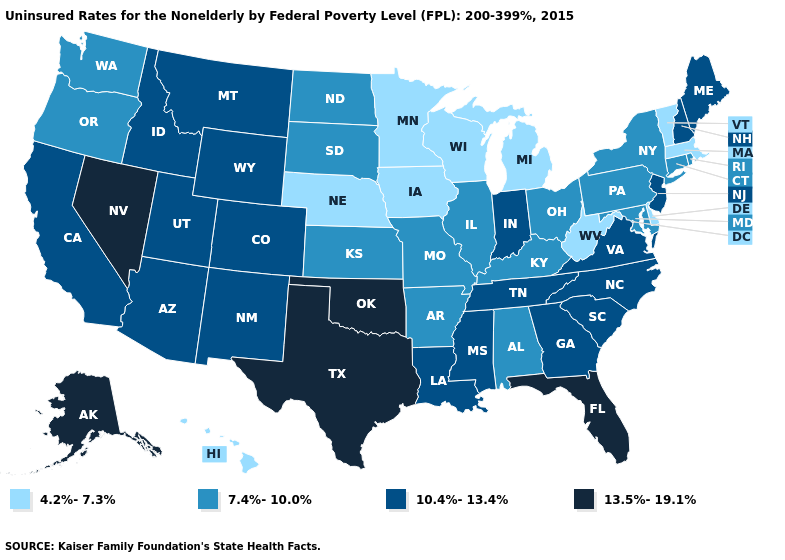Which states have the lowest value in the USA?
Short answer required. Delaware, Hawaii, Iowa, Massachusetts, Michigan, Minnesota, Nebraska, Vermont, West Virginia, Wisconsin. Does Wisconsin have the lowest value in the MidWest?
Write a very short answer. Yes. What is the value of Washington?
Quick response, please. 7.4%-10.0%. What is the value of North Dakota?
Short answer required. 7.4%-10.0%. How many symbols are there in the legend?
Short answer required. 4. Does Tennessee have a higher value than West Virginia?
Keep it brief. Yes. What is the highest value in the MidWest ?
Be succinct. 10.4%-13.4%. What is the value of New Hampshire?
Be succinct. 10.4%-13.4%. What is the value of Alabama?
Keep it brief. 7.4%-10.0%. What is the lowest value in the USA?
Quick response, please. 4.2%-7.3%. Name the states that have a value in the range 4.2%-7.3%?
Be succinct. Delaware, Hawaii, Iowa, Massachusetts, Michigan, Minnesota, Nebraska, Vermont, West Virginia, Wisconsin. Which states have the lowest value in the USA?
Short answer required. Delaware, Hawaii, Iowa, Massachusetts, Michigan, Minnesota, Nebraska, Vermont, West Virginia, Wisconsin. What is the lowest value in states that border Connecticut?
Concise answer only. 4.2%-7.3%. What is the value of Montana?
Give a very brief answer. 10.4%-13.4%. Does Arizona have the highest value in the USA?
Concise answer only. No. 